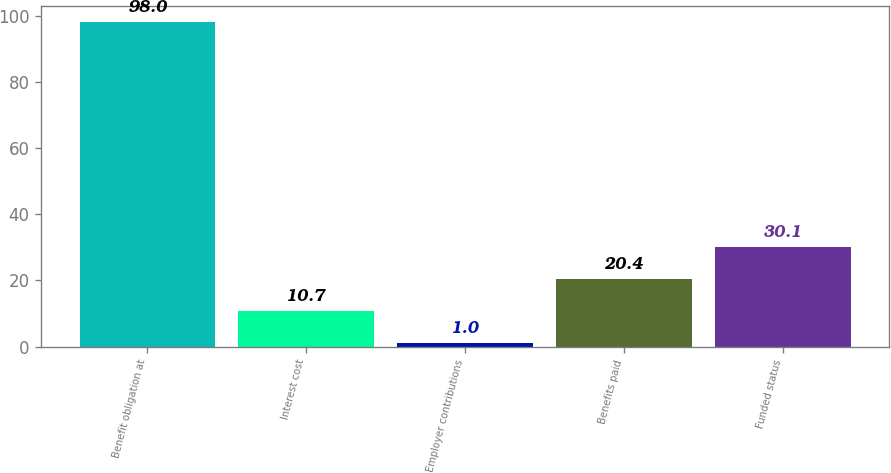<chart> <loc_0><loc_0><loc_500><loc_500><bar_chart><fcel>Benefit obligation at<fcel>Interest cost<fcel>Employer contributions<fcel>Benefits paid<fcel>Funded status<nl><fcel>98<fcel>10.7<fcel>1<fcel>20.4<fcel>30.1<nl></chart> 